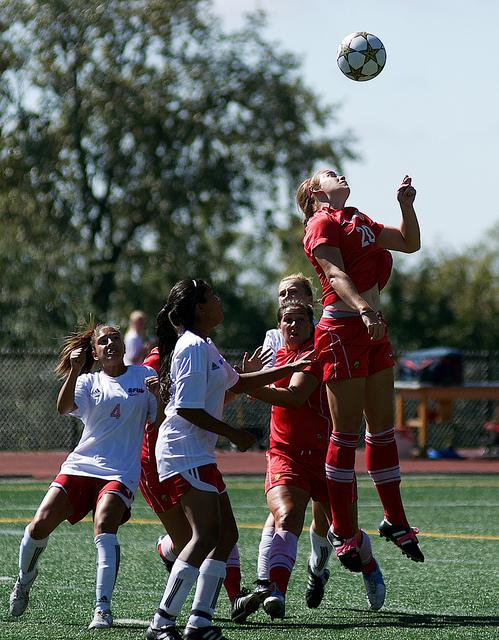How high did #20 jump?
Quick response, please. Very high. What game are they playing?
Answer briefly. Soccer. What does the read Jersey say?
Write a very short answer. 20. Will she catch the ball?
Keep it brief. No. What is the person in the red shirt about the catch?
Short answer required. Soccer ball. 